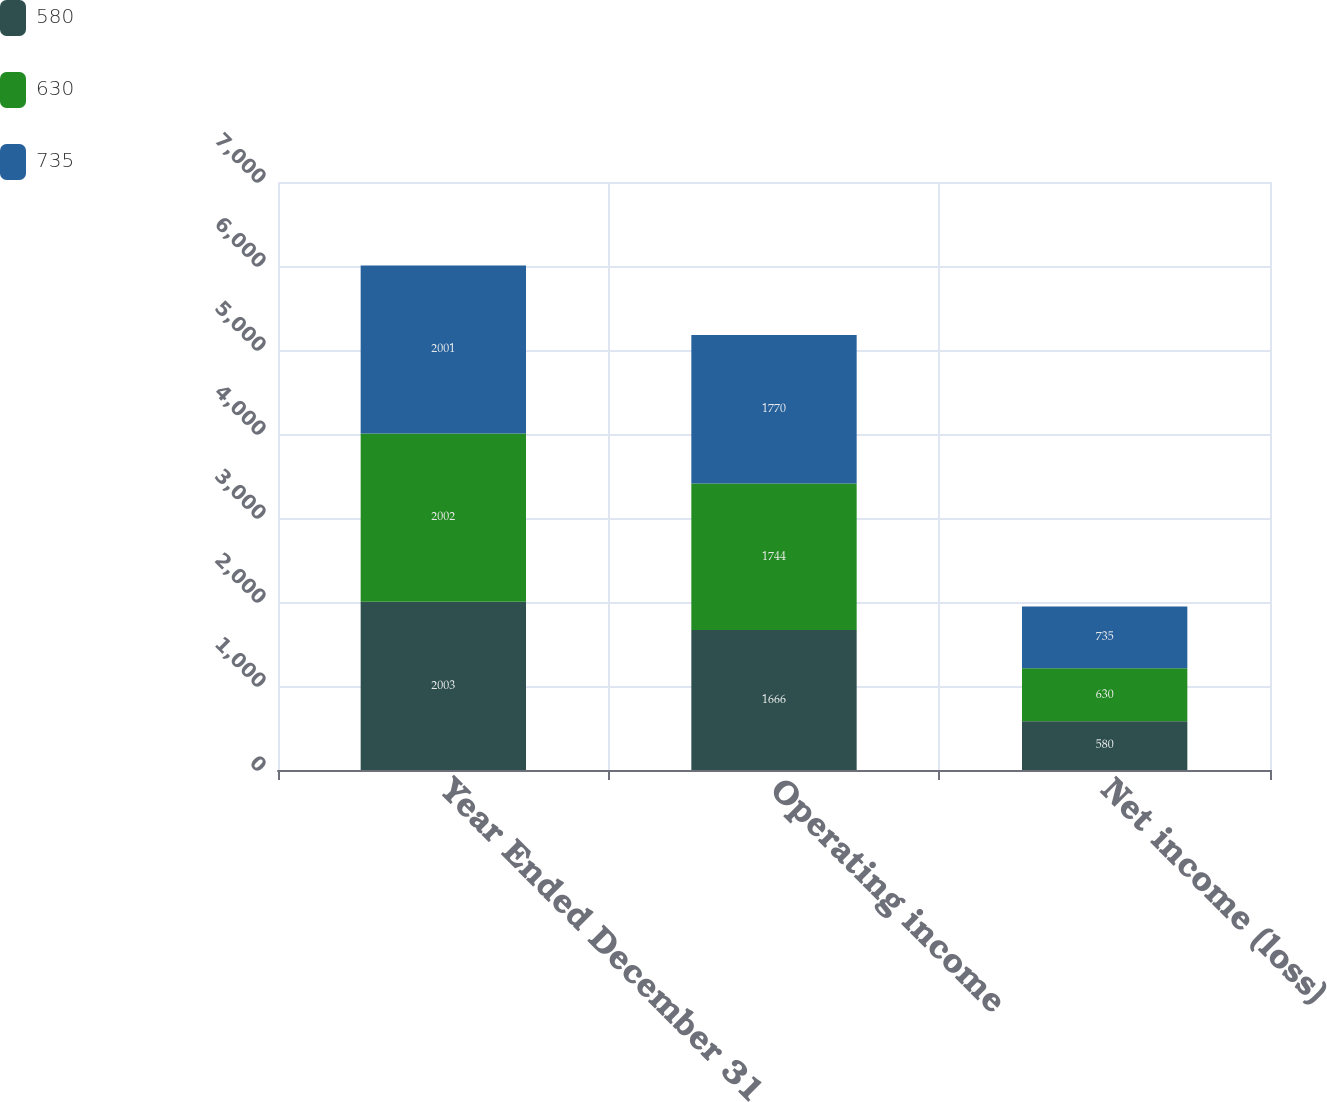<chart> <loc_0><loc_0><loc_500><loc_500><stacked_bar_chart><ecel><fcel>Year Ended December 31<fcel>Operating income<fcel>Net income (loss)<nl><fcel>580<fcel>2003<fcel>1666<fcel>580<nl><fcel>630<fcel>2002<fcel>1744<fcel>630<nl><fcel>735<fcel>2001<fcel>1770<fcel>735<nl></chart> 